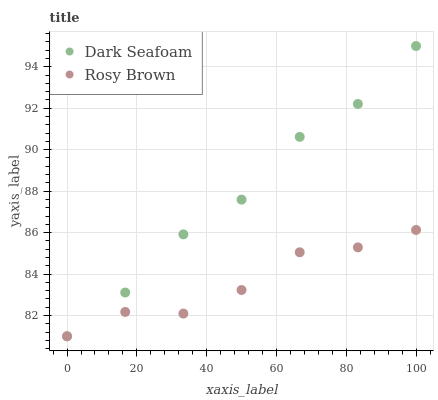Does Rosy Brown have the minimum area under the curve?
Answer yes or no. Yes. Does Dark Seafoam have the maximum area under the curve?
Answer yes or no. Yes. Does Rosy Brown have the maximum area under the curve?
Answer yes or no. No. Is Rosy Brown the smoothest?
Answer yes or no. Yes. Is Dark Seafoam the roughest?
Answer yes or no. Yes. Is Rosy Brown the roughest?
Answer yes or no. No. Does Dark Seafoam have the lowest value?
Answer yes or no. Yes. Does Dark Seafoam have the highest value?
Answer yes or no. Yes. Does Rosy Brown have the highest value?
Answer yes or no. No. Does Rosy Brown intersect Dark Seafoam?
Answer yes or no. Yes. Is Rosy Brown less than Dark Seafoam?
Answer yes or no. No. Is Rosy Brown greater than Dark Seafoam?
Answer yes or no. No. 